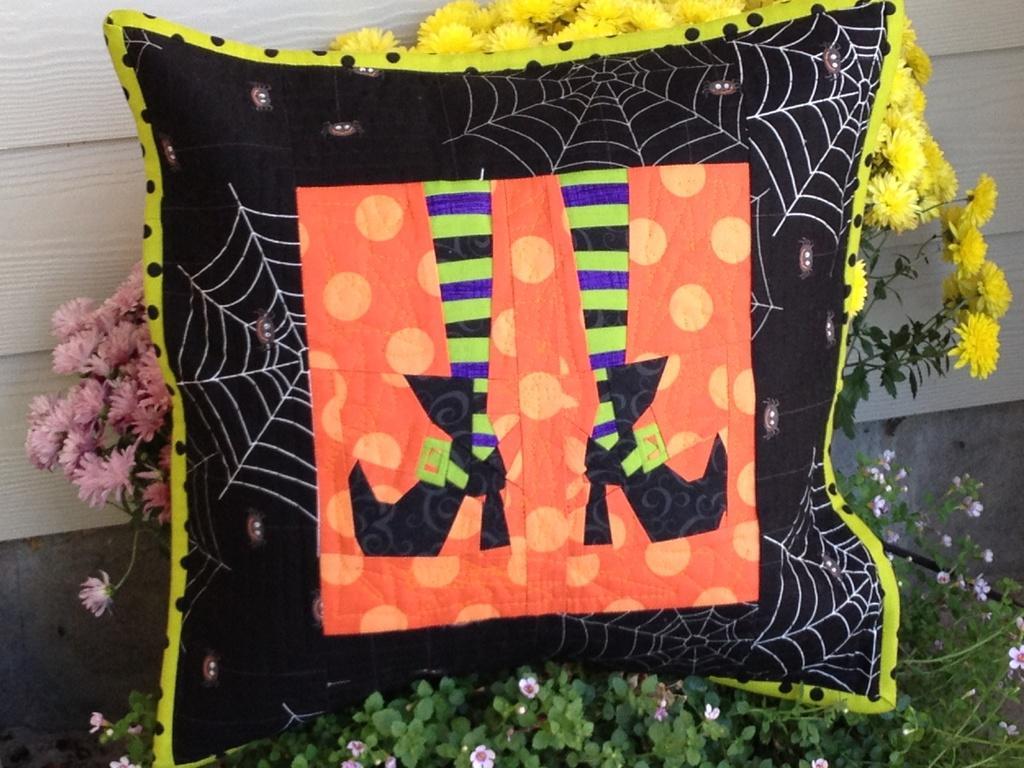Describe this image in one or two sentences. In this image we can see a pillow, flowers and we can also see the plants. 